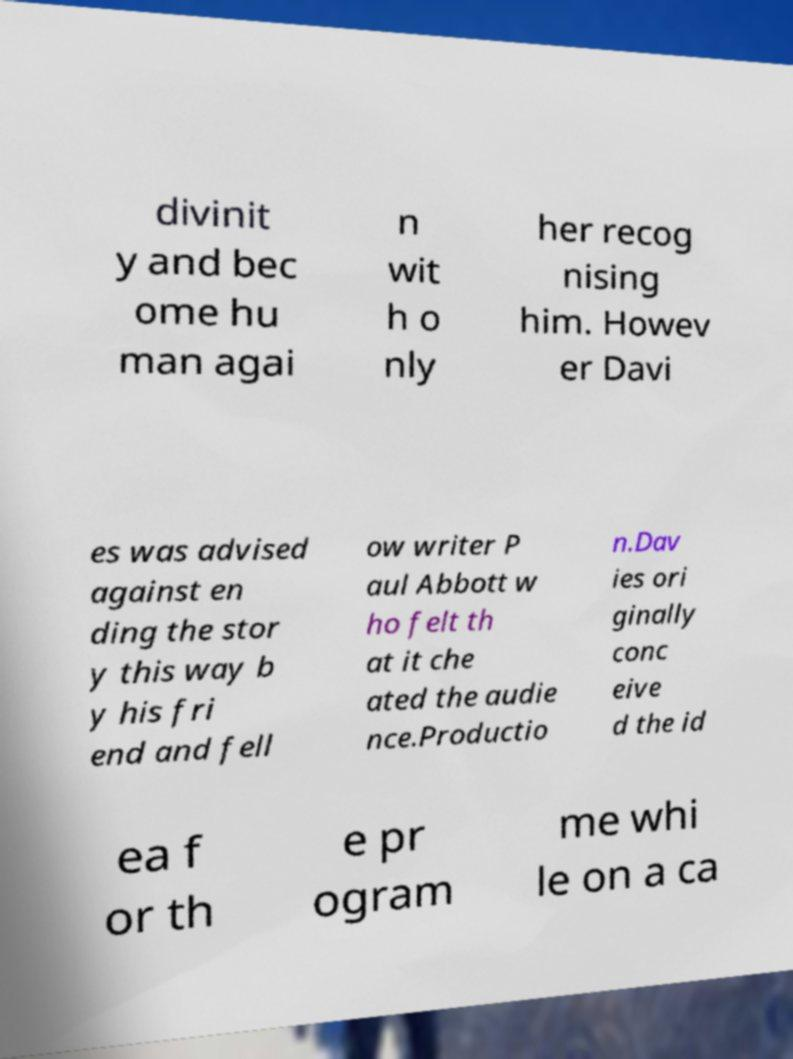Please read and relay the text visible in this image. What does it say? divinit y and bec ome hu man agai n wit h o nly her recog nising him. Howev er Davi es was advised against en ding the stor y this way b y his fri end and fell ow writer P aul Abbott w ho felt th at it che ated the audie nce.Productio n.Dav ies ori ginally conc eive d the id ea f or th e pr ogram me whi le on a ca 